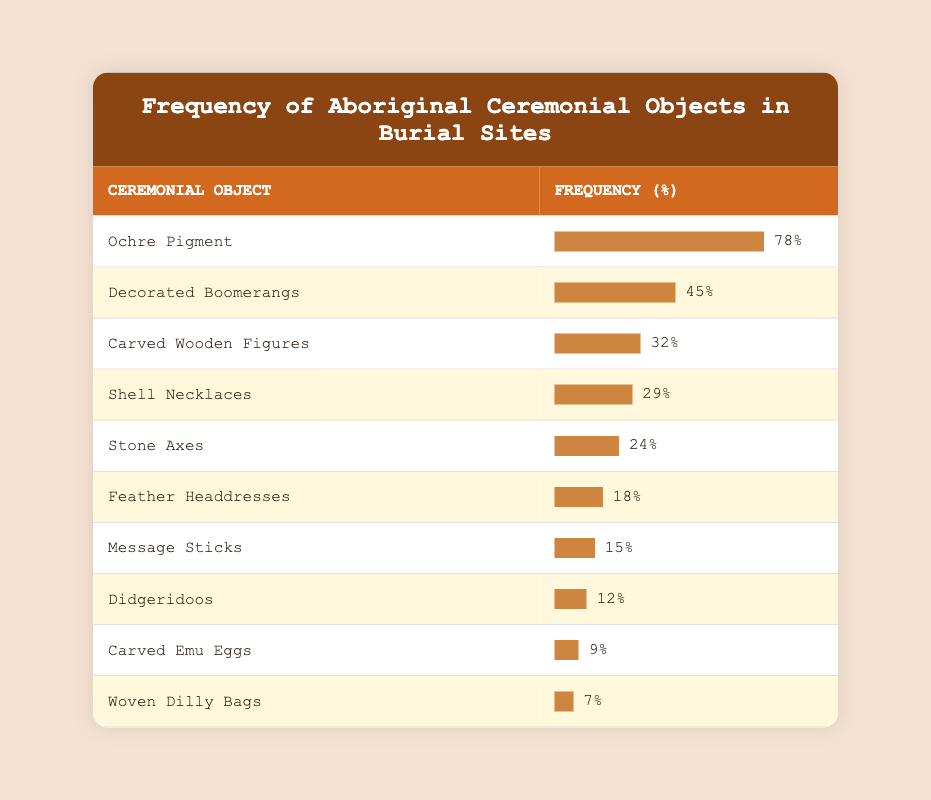What is the most frequently found ceremonial object? The table shows the frequency percentages for various ceremonial objects. The object with the highest frequency percentage is "Ochre Pigment," at 78%.
Answer: Ochre Pigment What percentage of burial sites had Feather Headdresses? According to the table, Feather Headdresses are found in 18% of the burial sites.
Answer: 18% How many ceremonial objects have a frequency of less than 10%? The table lists four objects with frequencies less than 10%: Carved Emu Eggs (9%) and Woven Dilly Bags (7%). Therefore, there are 2 objects.
Answer: 2 What is the average frequency of all the ceremonial objects listed? First, we sum the frequencies: 78 + 45 + 32 + 29 + 24 + 18 + 15 + 12 + 9 + 7 =  329. There are 10 objects, so the average frequency is 329 / 10 = 32.9%.
Answer: 32.9% Is the frequency of Shell Necklaces higher than that of Stone Axes? Shell Necklaces have a frequency of 29%, while Stone Axes have a frequency of 24%. Therefore, yes, Shell Necklaces are found more often than Stone Axes.
Answer: Yes Which ceremonial object has a frequency difference of 30% or more compared to Message Sticks? Decorated Boomerangs (45%) and Carved Wooden Figures (32%) are both found at a frequency that exceeds Message Sticks (15%) by more than 30%. This indicates two objects meet this criteria.
Answer: 2 Are Didgeridoos found in more burial sites than Carved Emu Eggs? Didgeridoos are found in 12% of sites, while Carved Emu Eggs are found in 9%. Comparing these, Didgeridoos are indeed more frequent.
Answer: Yes What is the cumulative frequency of the top three ceremonial objects? The top three objects are Ochre Pigment (78%), Decorated Boomerangs (45%), and Carved Wooden Figures (32%). Their cumulative frequency is calculated as 78 + 45 + 32 = 155%.
Answer: 155% Which two objects together account for more than half of the ceremonial objects found? Adding the frequencies of the top two objects, Ochre Pigment (78%) and Decorated Boomerangs (45%), gives 123%, which is more than half (50%). Therefore, these two objects together surpass the half mark.
Answer: Yes 